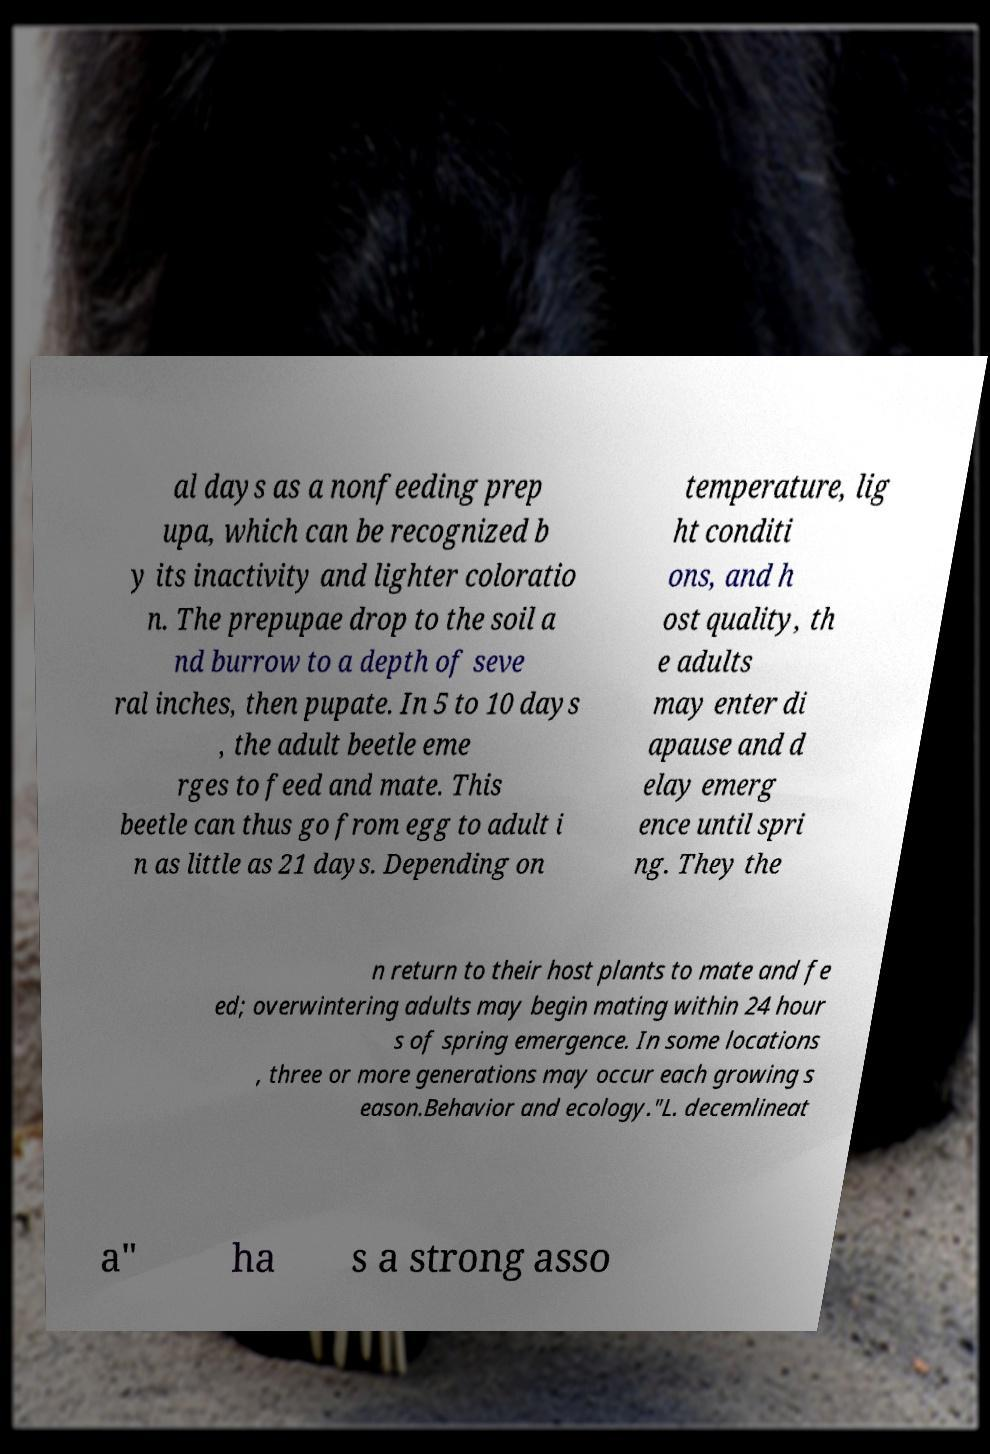There's text embedded in this image that I need extracted. Can you transcribe it verbatim? al days as a nonfeeding prep upa, which can be recognized b y its inactivity and lighter coloratio n. The prepupae drop to the soil a nd burrow to a depth of seve ral inches, then pupate. In 5 to 10 days , the adult beetle eme rges to feed and mate. This beetle can thus go from egg to adult i n as little as 21 days. Depending on temperature, lig ht conditi ons, and h ost quality, th e adults may enter di apause and d elay emerg ence until spri ng. They the n return to their host plants to mate and fe ed; overwintering adults may begin mating within 24 hour s of spring emergence. In some locations , three or more generations may occur each growing s eason.Behavior and ecology."L. decemlineat a" ha s a strong asso 